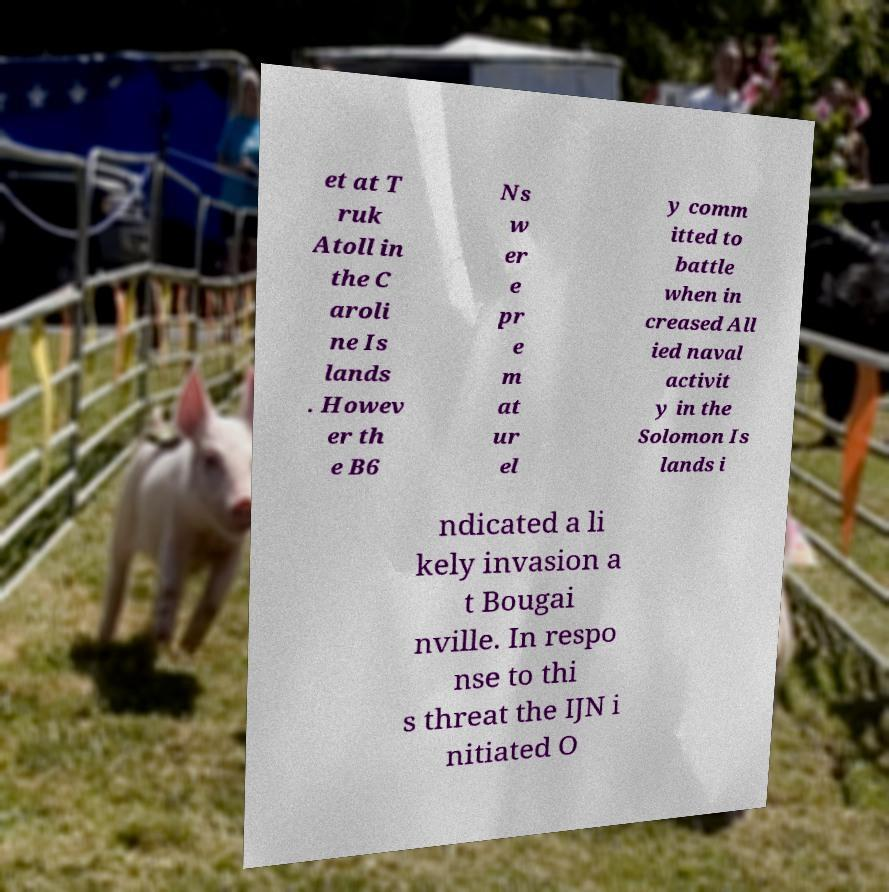What messages or text are displayed in this image? I need them in a readable, typed format. et at T ruk Atoll in the C aroli ne Is lands . Howev er th e B6 Ns w er e pr e m at ur el y comm itted to battle when in creased All ied naval activit y in the Solomon Is lands i ndicated a li kely invasion a t Bougai nville. In respo nse to thi s threat the IJN i nitiated O 